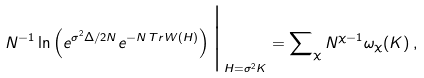Convert formula to latex. <formula><loc_0><loc_0><loc_500><loc_500>N ^ { - 1 } \ln \left ( e ^ { \sigma ^ { 2 } \Delta / 2 N } e ^ { - N \, T r \, W ( H ) } \right ) \Big | _ { H = \sigma ^ { 2 } K } = \sum \nolimits _ { \chi } N ^ { \chi - 1 } \omega _ { \chi } ( K ) \, ,</formula> 